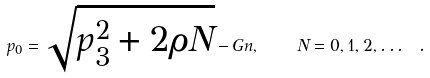Convert formula to latex. <formula><loc_0><loc_0><loc_500><loc_500>p _ { 0 } = \sqrt { p _ { 3 } ^ { 2 } + 2 \rho N } - G n , \quad N = 0 , 1 , 2 , \dots \ .</formula> 